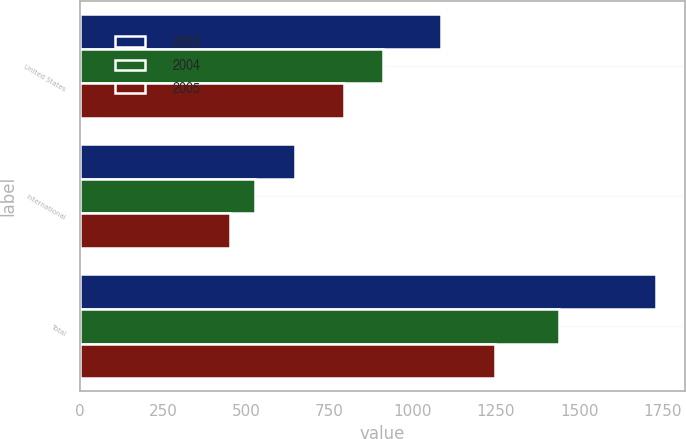<chart> <loc_0><loc_0><loc_500><loc_500><stacked_bar_chart><ecel><fcel>United States<fcel>International<fcel>Total<nl><fcel>2003<fcel>1085.4<fcel>646.2<fcel>1731.6<nl><fcel>2004<fcel>911.2<fcel>527.1<fcel>1438.3<nl><fcel>2005<fcel>795.3<fcel>451.3<fcel>1246.6<nl></chart> 